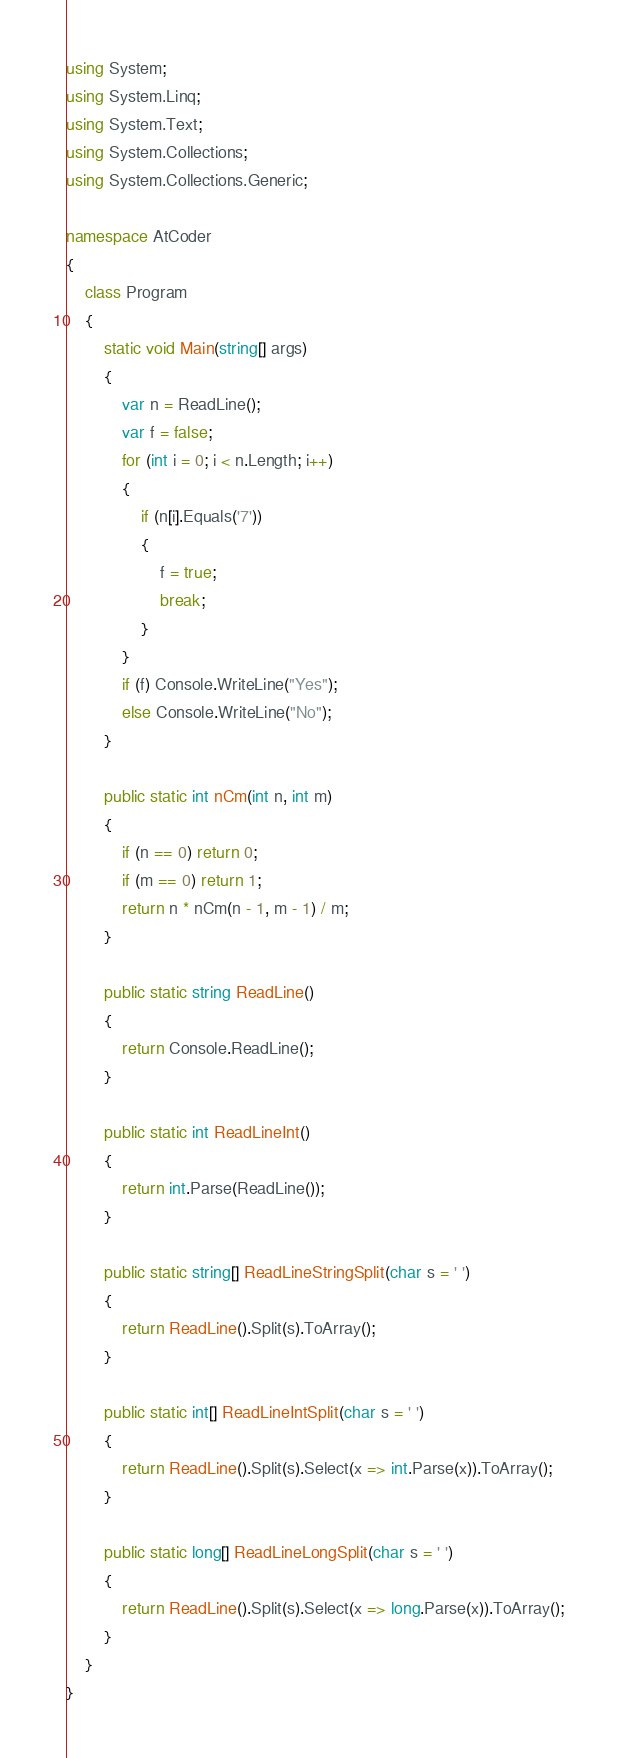<code> <loc_0><loc_0><loc_500><loc_500><_C#_>using System;
using System.Linq;
using System.Text;
using System.Collections;
using System.Collections.Generic;

namespace AtCoder
{
	class Program
	{
		static void Main(string[] args)
		{
			var n = ReadLine();
			var f = false;
			for (int i = 0; i < n.Length; i++)
			{
				if (n[i].Equals('7'))
				{
					f = true;
					break;
				}
			}
			if (f) Console.WriteLine("Yes");
			else Console.WriteLine("No");
		}

		public static int nCm(int n, int m)
		{
			if (n == 0) return 0;
			if (m == 0) return 1;
			return n * nCm(n - 1, m - 1) / m;
		}

		public static string ReadLine()
		{
			return Console.ReadLine();
		}

		public static int ReadLineInt()
		{
			return int.Parse(ReadLine());
		}

		public static string[] ReadLineStringSplit(char s = ' ')
		{
			return ReadLine().Split(s).ToArray();
		}

		public static int[] ReadLineIntSplit(char s = ' ')
		{
			return ReadLine().Split(s).Select(x => int.Parse(x)).ToArray();
		}

		public static long[] ReadLineLongSplit(char s = ' ')
		{
			return ReadLine().Split(s).Select(x => long.Parse(x)).ToArray();
		}
	}
}</code> 